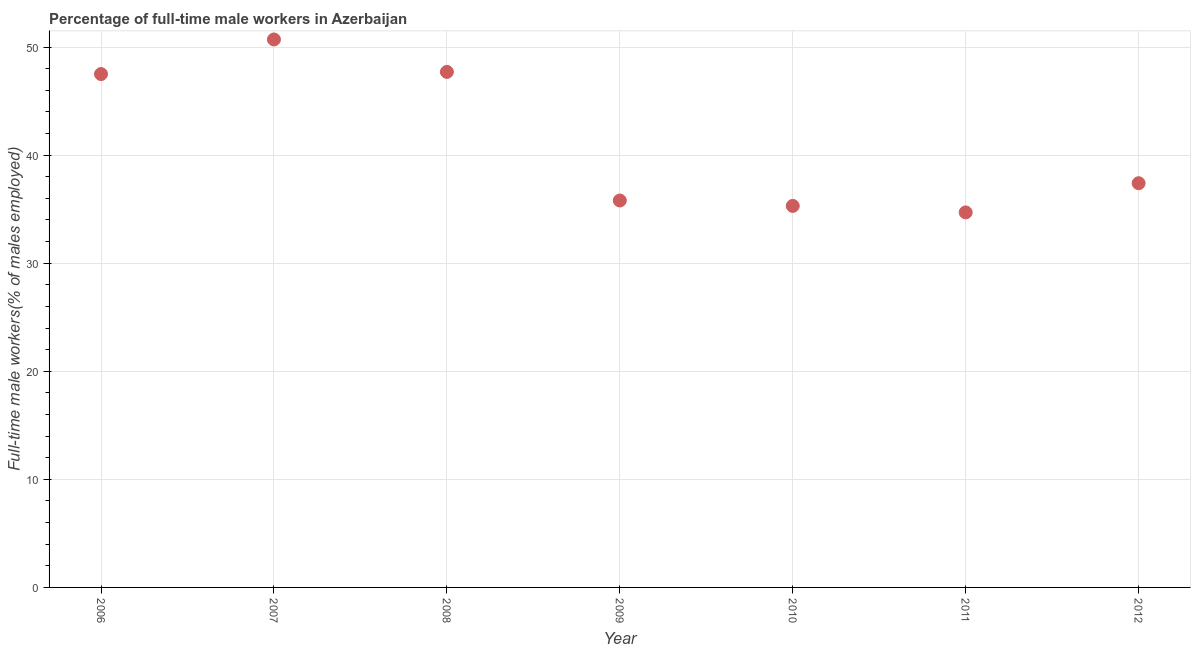What is the percentage of full-time male workers in 2012?
Provide a succinct answer. 37.4. Across all years, what is the maximum percentage of full-time male workers?
Ensure brevity in your answer.  50.7. Across all years, what is the minimum percentage of full-time male workers?
Offer a very short reply. 34.7. In which year was the percentage of full-time male workers minimum?
Make the answer very short. 2011. What is the sum of the percentage of full-time male workers?
Provide a succinct answer. 289.1. What is the difference between the percentage of full-time male workers in 2008 and 2010?
Keep it short and to the point. 12.4. What is the average percentage of full-time male workers per year?
Offer a very short reply. 41.3. What is the median percentage of full-time male workers?
Your answer should be compact. 37.4. Do a majority of the years between 2007 and 2010 (inclusive) have percentage of full-time male workers greater than 44 %?
Give a very brief answer. No. What is the ratio of the percentage of full-time male workers in 2008 to that in 2012?
Make the answer very short. 1.28. Is the percentage of full-time male workers in 2008 less than that in 2009?
Offer a terse response. No. Is the difference between the percentage of full-time male workers in 2007 and 2010 greater than the difference between any two years?
Make the answer very short. No. What is the difference between the highest and the second highest percentage of full-time male workers?
Make the answer very short. 3. Is the sum of the percentage of full-time male workers in 2008 and 2010 greater than the maximum percentage of full-time male workers across all years?
Make the answer very short. Yes. What is the difference between the highest and the lowest percentage of full-time male workers?
Ensure brevity in your answer.  16. Does the percentage of full-time male workers monotonically increase over the years?
Your answer should be very brief. No. How many dotlines are there?
Offer a very short reply. 1. How many years are there in the graph?
Your answer should be very brief. 7. What is the difference between two consecutive major ticks on the Y-axis?
Your response must be concise. 10. Are the values on the major ticks of Y-axis written in scientific E-notation?
Make the answer very short. No. Does the graph contain any zero values?
Provide a succinct answer. No. Does the graph contain grids?
Provide a short and direct response. Yes. What is the title of the graph?
Your answer should be very brief. Percentage of full-time male workers in Azerbaijan. What is the label or title of the Y-axis?
Keep it short and to the point. Full-time male workers(% of males employed). What is the Full-time male workers(% of males employed) in 2006?
Offer a terse response. 47.5. What is the Full-time male workers(% of males employed) in 2007?
Provide a short and direct response. 50.7. What is the Full-time male workers(% of males employed) in 2008?
Your answer should be very brief. 47.7. What is the Full-time male workers(% of males employed) in 2009?
Provide a short and direct response. 35.8. What is the Full-time male workers(% of males employed) in 2010?
Your response must be concise. 35.3. What is the Full-time male workers(% of males employed) in 2011?
Provide a short and direct response. 34.7. What is the Full-time male workers(% of males employed) in 2012?
Offer a terse response. 37.4. What is the difference between the Full-time male workers(% of males employed) in 2006 and 2008?
Offer a very short reply. -0.2. What is the difference between the Full-time male workers(% of males employed) in 2006 and 2009?
Keep it short and to the point. 11.7. What is the difference between the Full-time male workers(% of males employed) in 2006 and 2010?
Make the answer very short. 12.2. What is the difference between the Full-time male workers(% of males employed) in 2006 and 2011?
Offer a very short reply. 12.8. What is the difference between the Full-time male workers(% of males employed) in 2007 and 2008?
Ensure brevity in your answer.  3. What is the difference between the Full-time male workers(% of males employed) in 2007 and 2010?
Keep it short and to the point. 15.4. What is the difference between the Full-time male workers(% of males employed) in 2007 and 2011?
Provide a succinct answer. 16. What is the difference between the Full-time male workers(% of males employed) in 2007 and 2012?
Your answer should be very brief. 13.3. What is the difference between the Full-time male workers(% of males employed) in 2008 and 2012?
Your response must be concise. 10.3. What is the difference between the Full-time male workers(% of males employed) in 2009 and 2011?
Your answer should be very brief. 1.1. What is the difference between the Full-time male workers(% of males employed) in 2010 and 2011?
Offer a terse response. 0.6. What is the ratio of the Full-time male workers(% of males employed) in 2006 to that in 2007?
Provide a succinct answer. 0.94. What is the ratio of the Full-time male workers(% of males employed) in 2006 to that in 2009?
Provide a short and direct response. 1.33. What is the ratio of the Full-time male workers(% of males employed) in 2006 to that in 2010?
Provide a short and direct response. 1.35. What is the ratio of the Full-time male workers(% of males employed) in 2006 to that in 2011?
Your answer should be very brief. 1.37. What is the ratio of the Full-time male workers(% of males employed) in 2006 to that in 2012?
Your answer should be very brief. 1.27. What is the ratio of the Full-time male workers(% of males employed) in 2007 to that in 2008?
Offer a very short reply. 1.06. What is the ratio of the Full-time male workers(% of males employed) in 2007 to that in 2009?
Provide a succinct answer. 1.42. What is the ratio of the Full-time male workers(% of males employed) in 2007 to that in 2010?
Keep it short and to the point. 1.44. What is the ratio of the Full-time male workers(% of males employed) in 2007 to that in 2011?
Your answer should be compact. 1.46. What is the ratio of the Full-time male workers(% of males employed) in 2007 to that in 2012?
Your answer should be very brief. 1.36. What is the ratio of the Full-time male workers(% of males employed) in 2008 to that in 2009?
Give a very brief answer. 1.33. What is the ratio of the Full-time male workers(% of males employed) in 2008 to that in 2010?
Give a very brief answer. 1.35. What is the ratio of the Full-time male workers(% of males employed) in 2008 to that in 2011?
Offer a very short reply. 1.38. What is the ratio of the Full-time male workers(% of males employed) in 2008 to that in 2012?
Provide a short and direct response. 1.27. What is the ratio of the Full-time male workers(% of males employed) in 2009 to that in 2010?
Offer a terse response. 1.01. What is the ratio of the Full-time male workers(% of males employed) in 2009 to that in 2011?
Your response must be concise. 1.03. What is the ratio of the Full-time male workers(% of males employed) in 2009 to that in 2012?
Provide a short and direct response. 0.96. What is the ratio of the Full-time male workers(% of males employed) in 2010 to that in 2012?
Make the answer very short. 0.94. What is the ratio of the Full-time male workers(% of males employed) in 2011 to that in 2012?
Your response must be concise. 0.93. 